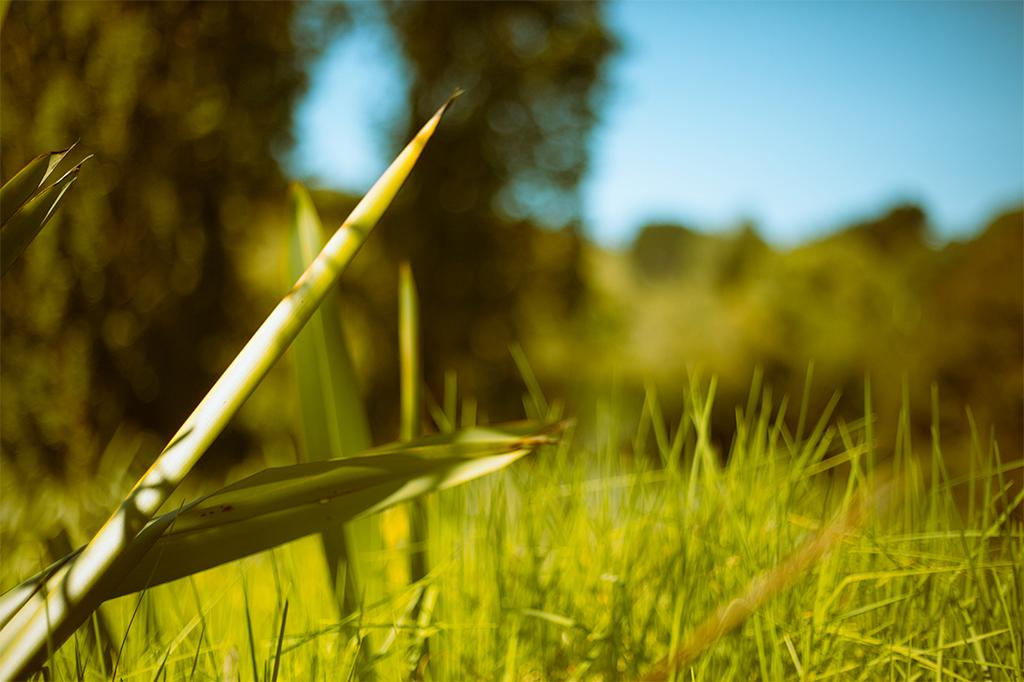What type of vegetation is present in the image? There is green grass in the image. Can you describe the background of the image? The background of the image is green and blurred. What part of the natural environment is visible in the image? The sky is visible in the background of the image. What type of toy can be seen falling from the sky in the image? There is no toy or any object falling from the sky in the image. 